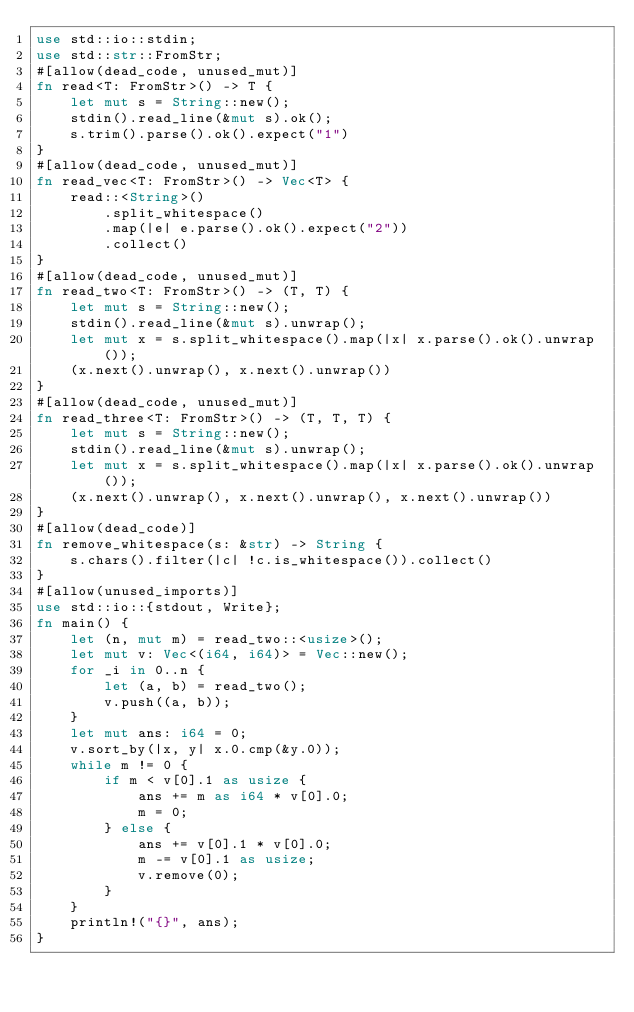<code> <loc_0><loc_0><loc_500><loc_500><_Rust_>use std::io::stdin;
use std::str::FromStr;
#[allow(dead_code, unused_mut)]
fn read<T: FromStr>() -> T {
    let mut s = String::new();
    stdin().read_line(&mut s).ok();
    s.trim().parse().ok().expect("1")
}
#[allow(dead_code, unused_mut)]
fn read_vec<T: FromStr>() -> Vec<T> {
    read::<String>()
        .split_whitespace()
        .map(|e| e.parse().ok().expect("2"))
        .collect()
}
#[allow(dead_code, unused_mut)]
fn read_two<T: FromStr>() -> (T, T) {
    let mut s = String::new();
    stdin().read_line(&mut s).unwrap();
    let mut x = s.split_whitespace().map(|x| x.parse().ok().unwrap());
    (x.next().unwrap(), x.next().unwrap())
}
#[allow(dead_code, unused_mut)]
fn read_three<T: FromStr>() -> (T, T, T) {
    let mut s = String::new();
    stdin().read_line(&mut s).unwrap();
    let mut x = s.split_whitespace().map(|x| x.parse().ok().unwrap());
    (x.next().unwrap(), x.next().unwrap(), x.next().unwrap())
}
#[allow(dead_code)]
fn remove_whitespace(s: &str) -> String {
    s.chars().filter(|c| !c.is_whitespace()).collect()
}
#[allow(unused_imports)]
use std::io::{stdout, Write};
fn main() {
    let (n, mut m) = read_two::<usize>();
    let mut v: Vec<(i64, i64)> = Vec::new();
    for _i in 0..n {
        let (a, b) = read_two();
        v.push((a, b));
    }
    let mut ans: i64 = 0;
    v.sort_by(|x, y| x.0.cmp(&y.0));
    while m != 0 {
        if m < v[0].1 as usize {
            ans += m as i64 * v[0].0;
            m = 0;
        } else {
            ans += v[0].1 * v[0].0;
            m -= v[0].1 as usize;
            v.remove(0);
        }
    }
    println!("{}", ans);
}
</code> 